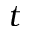<formula> <loc_0><loc_0><loc_500><loc_500>t</formula> 